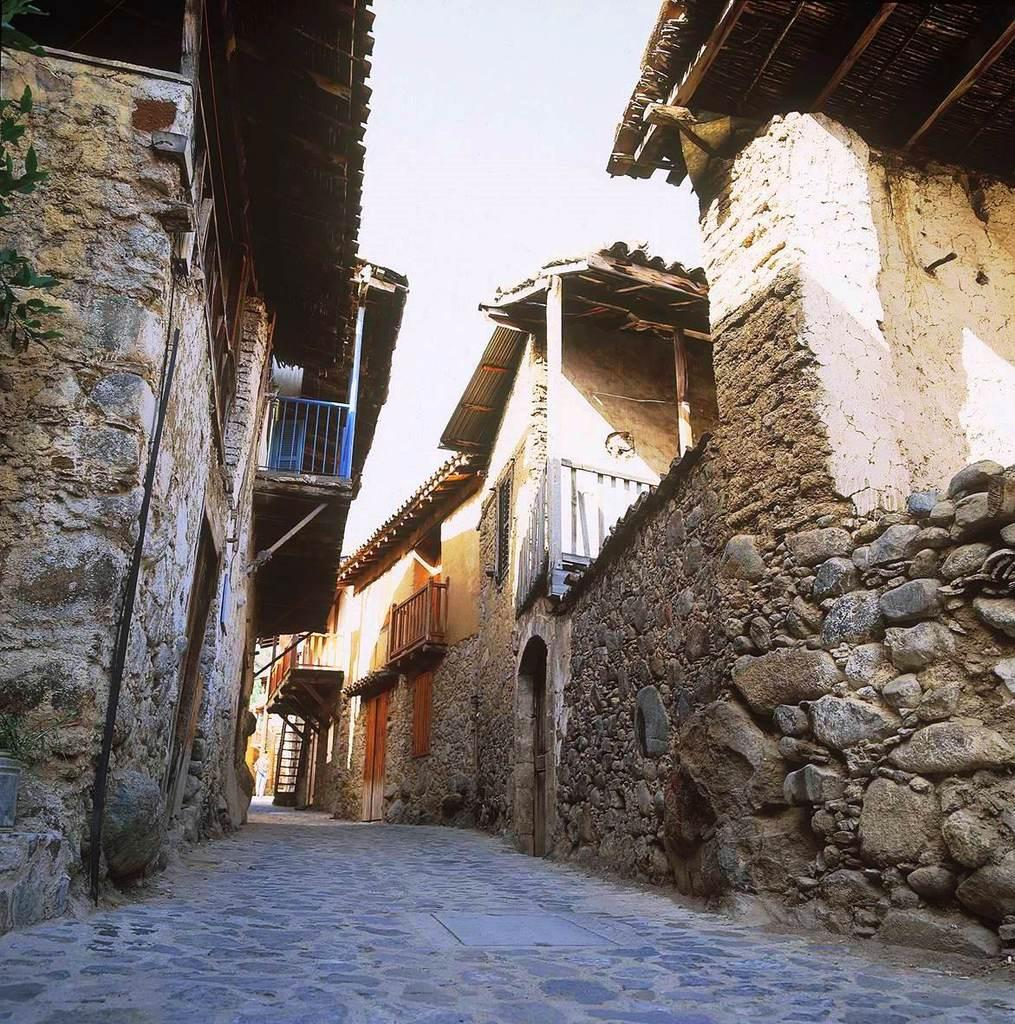What type of structures can be seen in the image? There are houses in the image. What celestial objects are visible in the image? Stars are visible in the image. How would you describe the sky in the image? The sky is cloudy in the image. How many bricks can be seen on the tongue of the dog in the image? There are no dogs or bricks present in the image. 